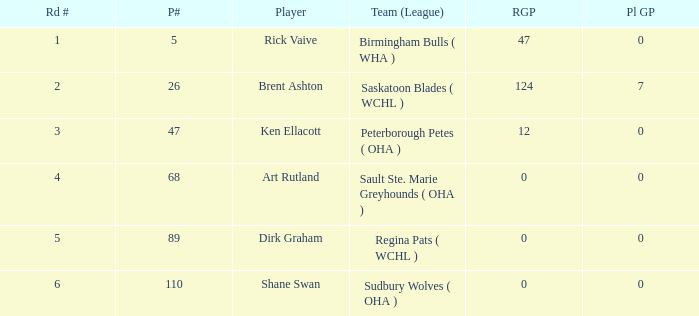How many reg GP for rick vaive in round 1? None. 